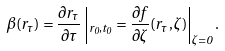<formula> <loc_0><loc_0><loc_500><loc_500>\beta ( r _ { \tau } ) = \frac { \partial r _ { \tau } } { \partial \tau } \left | _ { r _ { 0 } , t _ { 0 } } = \frac { \partial f } { \partial \zeta } ( r _ { \tau } , \zeta ) \right | _ { \zeta = 0 } .</formula> 